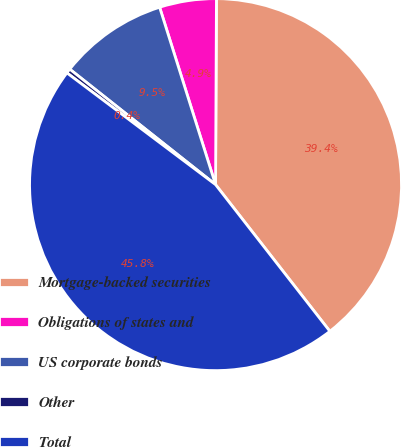Convert chart to OTSL. <chart><loc_0><loc_0><loc_500><loc_500><pie_chart><fcel>Mortgage-backed securities<fcel>Obligations of states and<fcel>US corporate bonds<fcel>Other<fcel>Total<nl><fcel>39.39%<fcel>4.94%<fcel>9.48%<fcel>0.4%<fcel>45.8%<nl></chart> 